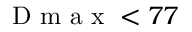<formula> <loc_0><loc_0><loc_500><loc_500>D m a x < 7 7</formula> 